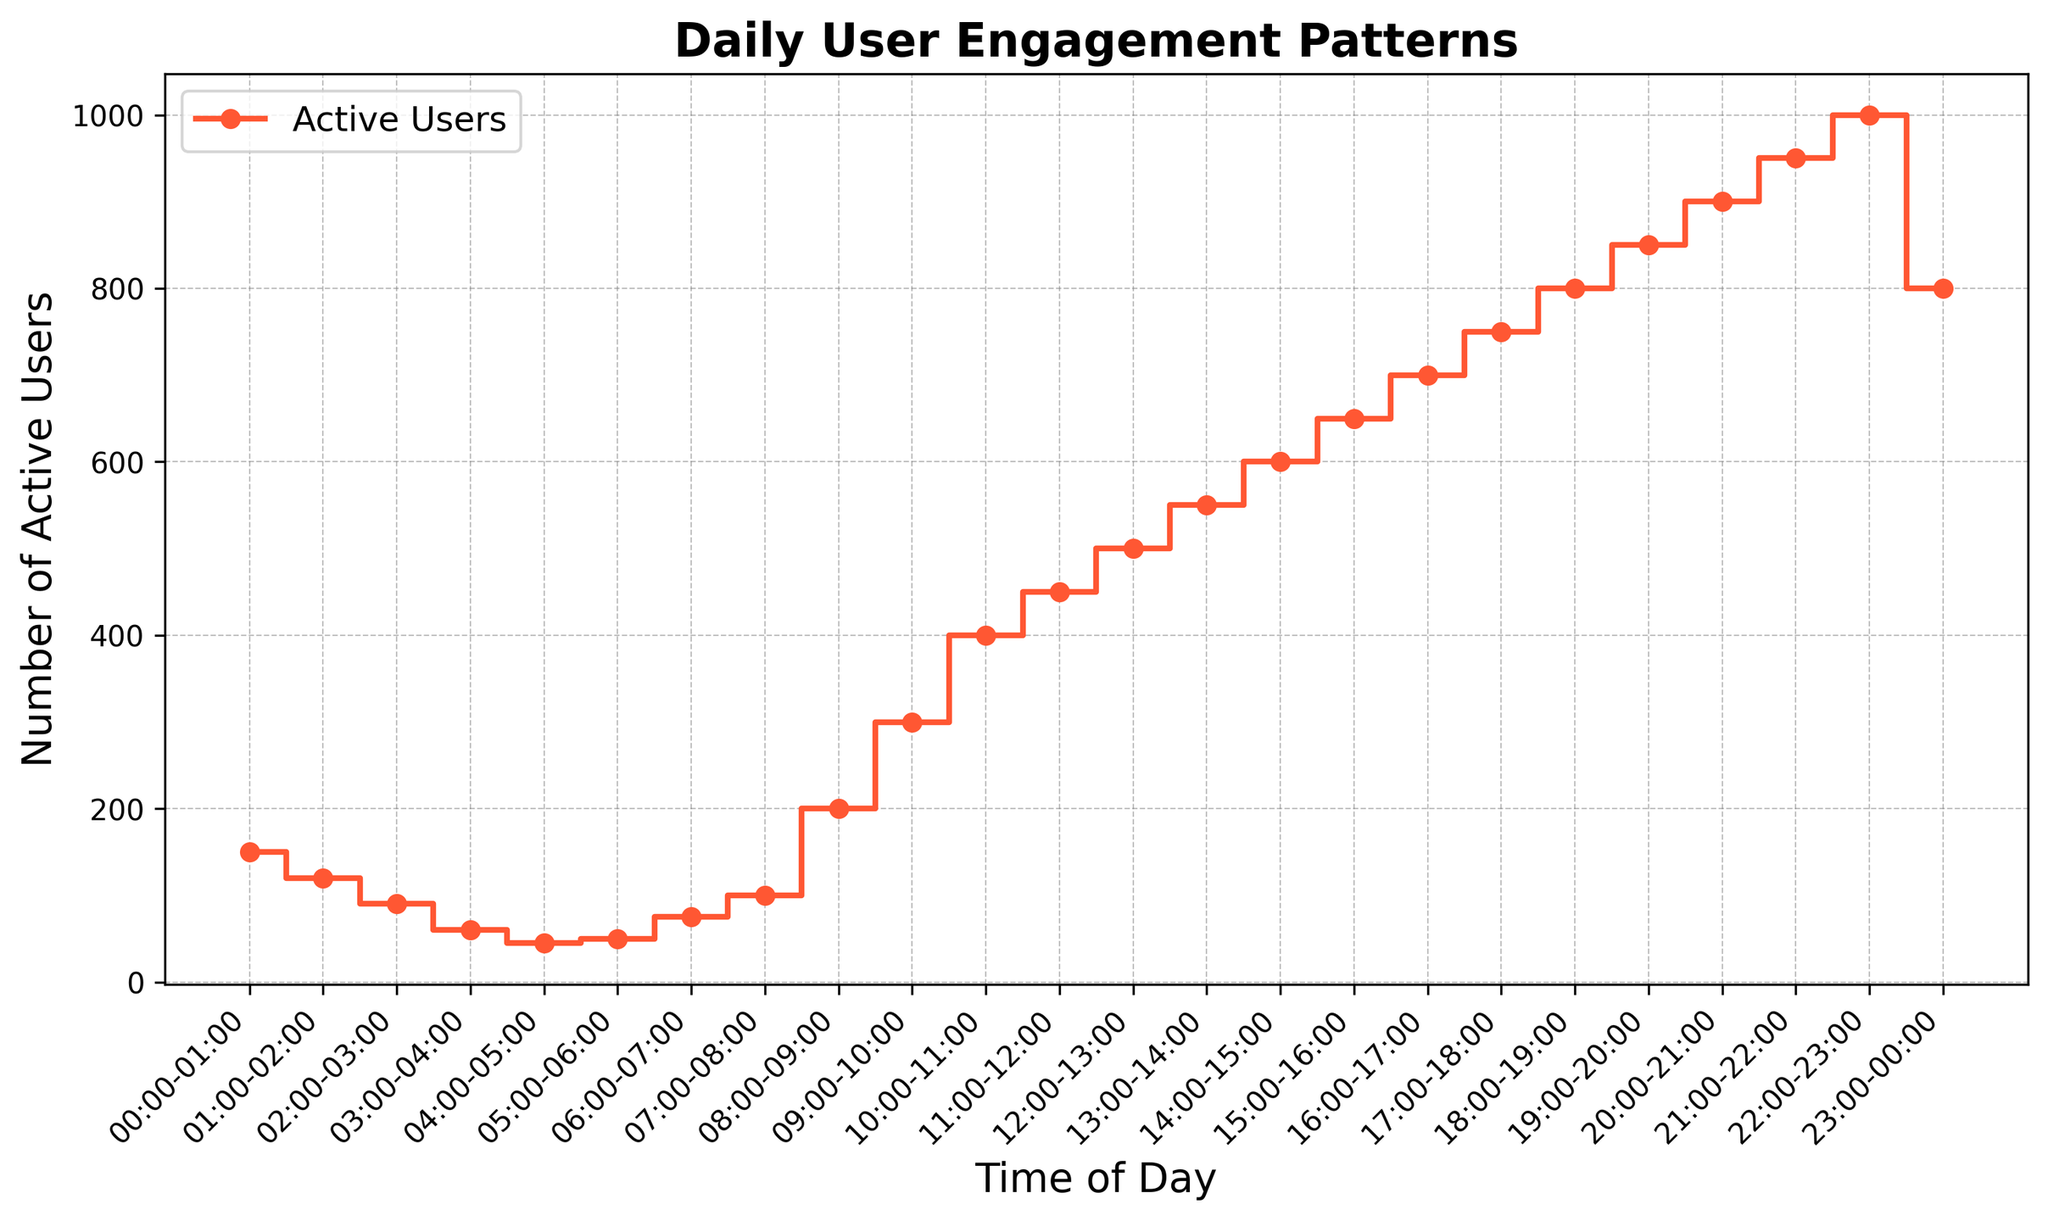what time of day sees the highest user engagement? By visually scanning the highest point on the plot, you'll see that the maximum number of active users is at the 22:00-23:00 interval, with 1000 active users.
Answer: 22:00-23:00 what is the difference in user engagement between 10:00 and 23:00? At 10:00-11:00, there are 400 active users, and at 23:00-00:00, there are 800 active users. The difference is 800 - 400 = 400 users.
Answer: 400 how does user engagement change from 03:00-04:00 to 06:00-07:00? The engagement at 03:00-04:00 is 60 users, and it increases to 75 users by 06:00-07:00, showing a gradual increase of 75 - 60 = 15 users.
Answer: Increases by 15 which time period has a more significant drop in user engagement: from 00:00-01:00 to 01:00-02:00 or from 04:00-05:00 to 05:00-06:00? From 00:00-01:00 to 01:00-02:00, users drop from 150 to 120, a difference of 30 users. From 04:00-05:00 to 05:00-06:00, users drop from 45 to 50, a unique case where there's a slight increase. Hence, the more significant drop is from 00:00-01:00 to 01:00-02:00, which is 30 users.
Answer: 00:00-01:00 to 01:00-02:00 is there a point where user engagement doubles within an hour? Check intervals where the number of active users at one time is at least twice the number at the previous one. This is true between 04:00-05:00 with 45 users to 05:00-06:00 with 50 users (not quite double though). A closer look shows 08:00-09:00 with 200 users to 09:00-10:00 with 300 users more nearly fits the criteria. Thus the interval 08:00-09:00 to 09:00-10:00 depicts almost double engagement increase.
Answer: 08:00-09:00 to 09:00-10:00 by how much does user engagement increase from 12:00-13:00 to 14:00-15:00? At 12:00-13:00, there are 500 active users. By 14:00-15:00, there are 600 users. The increase is 600 - 500 = 100 users.
Answer: Increases by 100 what's the average user engagement between 10:00 and 15:00? Sum the active users from 10:00 to 15:00 (400, 450, 500, 550, 600) which is 2500 users. Since there are 5 time intervals: 2500 / 5 = 500 users.
Answer: 500 what time of day has the least user engagement? By visually scanning the lowest point on the plot, the least user engagement is at 04:00-05:00, with only 45 active users.
Answer: 04:00-05:00 during which time period do user numbers first exceed 500? By following the plot, you'll observe the user numbers first exceed 500 at the 13:00-14:00 interval.
Answer: 13:00-14:00 